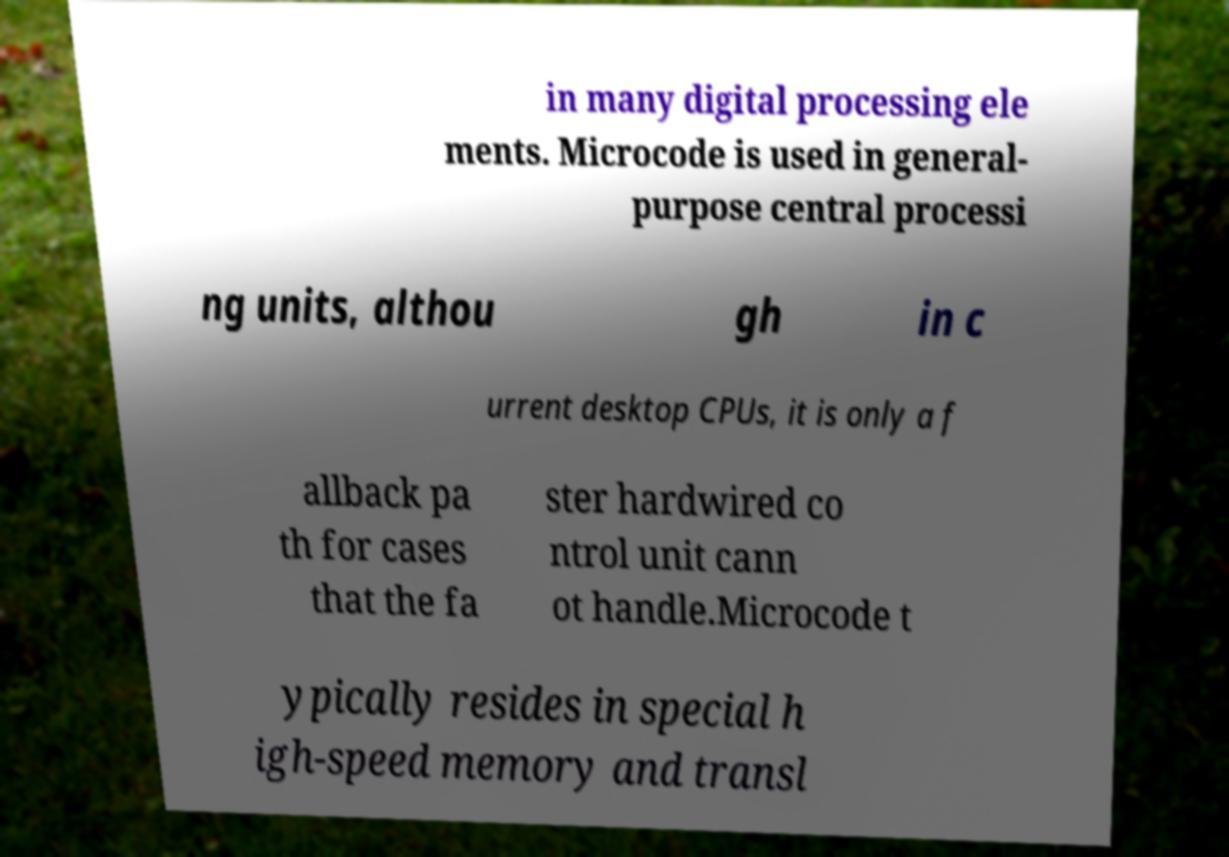There's text embedded in this image that I need extracted. Can you transcribe it verbatim? in many digital processing ele ments. Microcode is used in general- purpose central processi ng units, althou gh in c urrent desktop CPUs, it is only a f allback pa th for cases that the fa ster hardwired co ntrol unit cann ot handle.Microcode t ypically resides in special h igh-speed memory and transl 